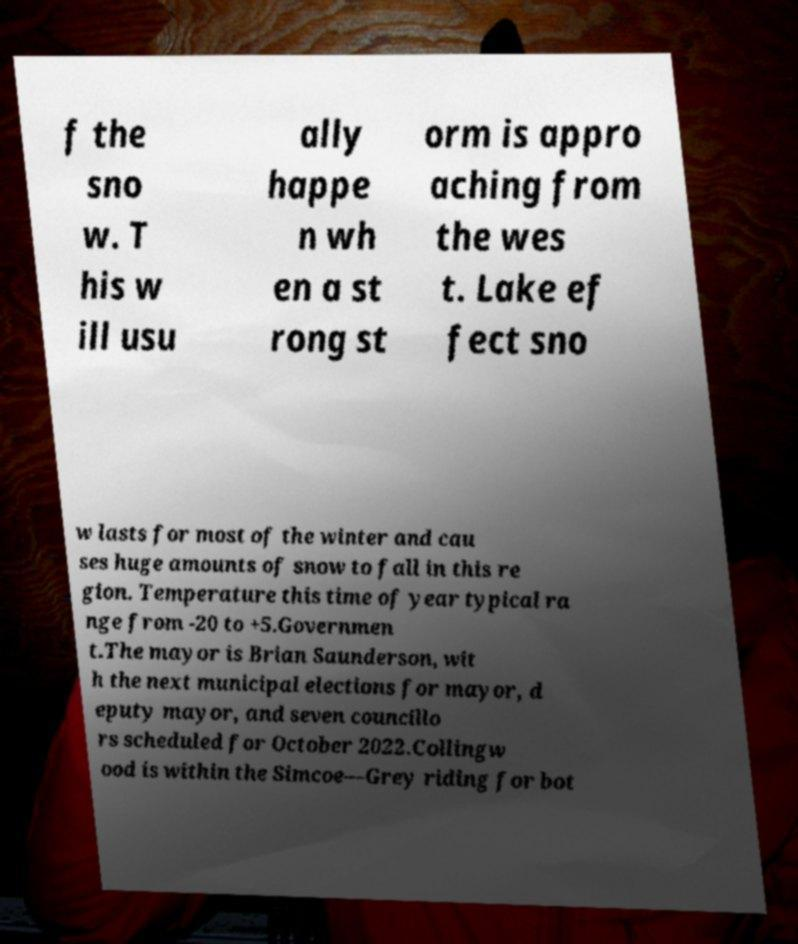Could you extract and type out the text from this image? f the sno w. T his w ill usu ally happe n wh en a st rong st orm is appro aching from the wes t. Lake ef fect sno w lasts for most of the winter and cau ses huge amounts of snow to fall in this re gion. Temperature this time of year typical ra nge from -20 to +5.Governmen t.The mayor is Brian Saunderson, wit h the next municipal elections for mayor, d eputy mayor, and seven councillo rs scheduled for October 2022.Collingw ood is within the Simcoe—Grey riding for bot 